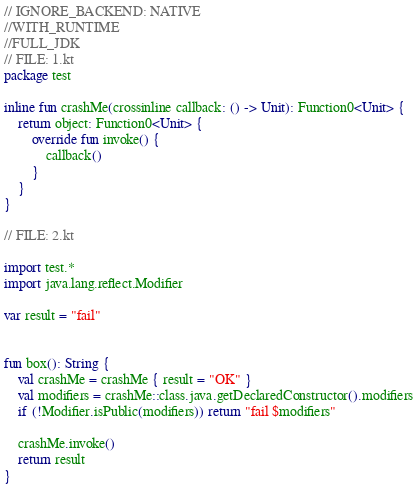<code> <loc_0><loc_0><loc_500><loc_500><_Kotlin_>// IGNORE_BACKEND: NATIVE
//WITH_RUNTIME
//FULL_JDK
// FILE: 1.kt
package test

inline fun crashMe(crossinline callback: () -> Unit): Function0<Unit> {
    return object: Function0<Unit> {
        override fun invoke() {
            callback()
        }
    }
}

// FILE: 2.kt

import test.*
import java.lang.reflect.Modifier

var result = "fail"


fun box(): String {
    val crashMe = crashMe { result = "OK" }
    val modifiers = crashMe::class.java.getDeclaredConstructor().modifiers
    if (!Modifier.isPublic(modifiers)) return "fail $modifiers"

    crashMe.invoke()
    return result
}</code> 